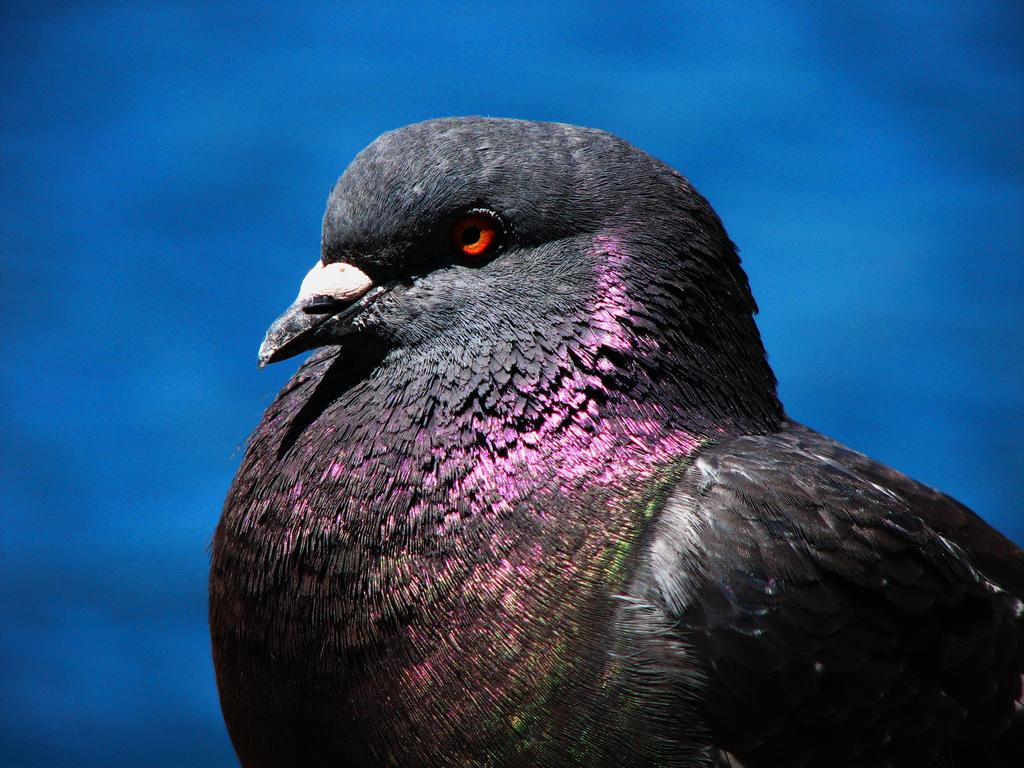What type of animal can be seen in the image? There is a bird in the image. What can be seen in the background of the image? The sky is visible in the background of the image. What type of knowledge is the bird working on in the image? There is no indication in the image that the bird is working on any knowledge or task. 